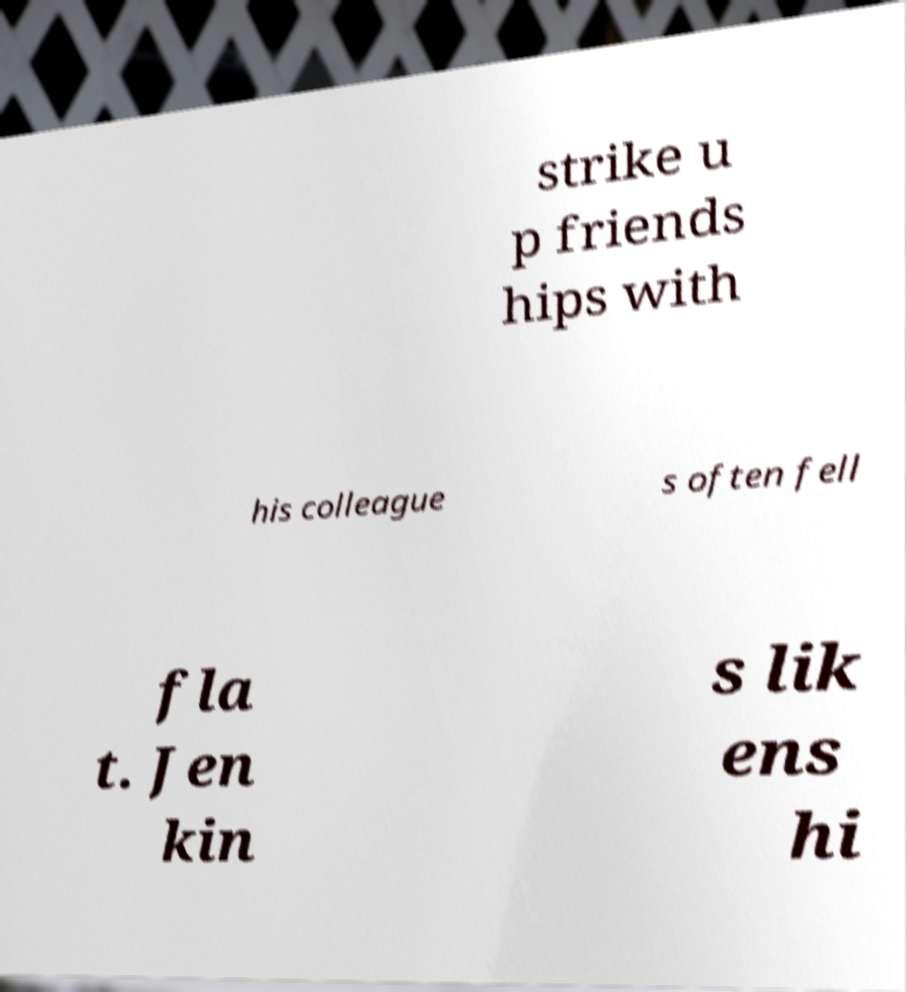Can you accurately transcribe the text from the provided image for me? strike u p friends hips with his colleague s often fell fla t. Jen kin s lik ens hi 